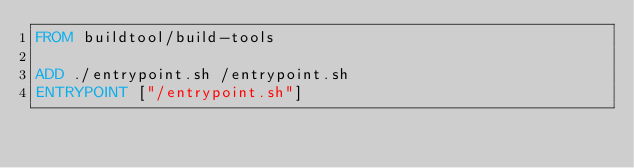Convert code to text. <code><loc_0><loc_0><loc_500><loc_500><_Dockerfile_>FROM buildtool/build-tools

ADD ./entrypoint.sh /entrypoint.sh
ENTRYPOINT ["/entrypoint.sh"]

</code> 